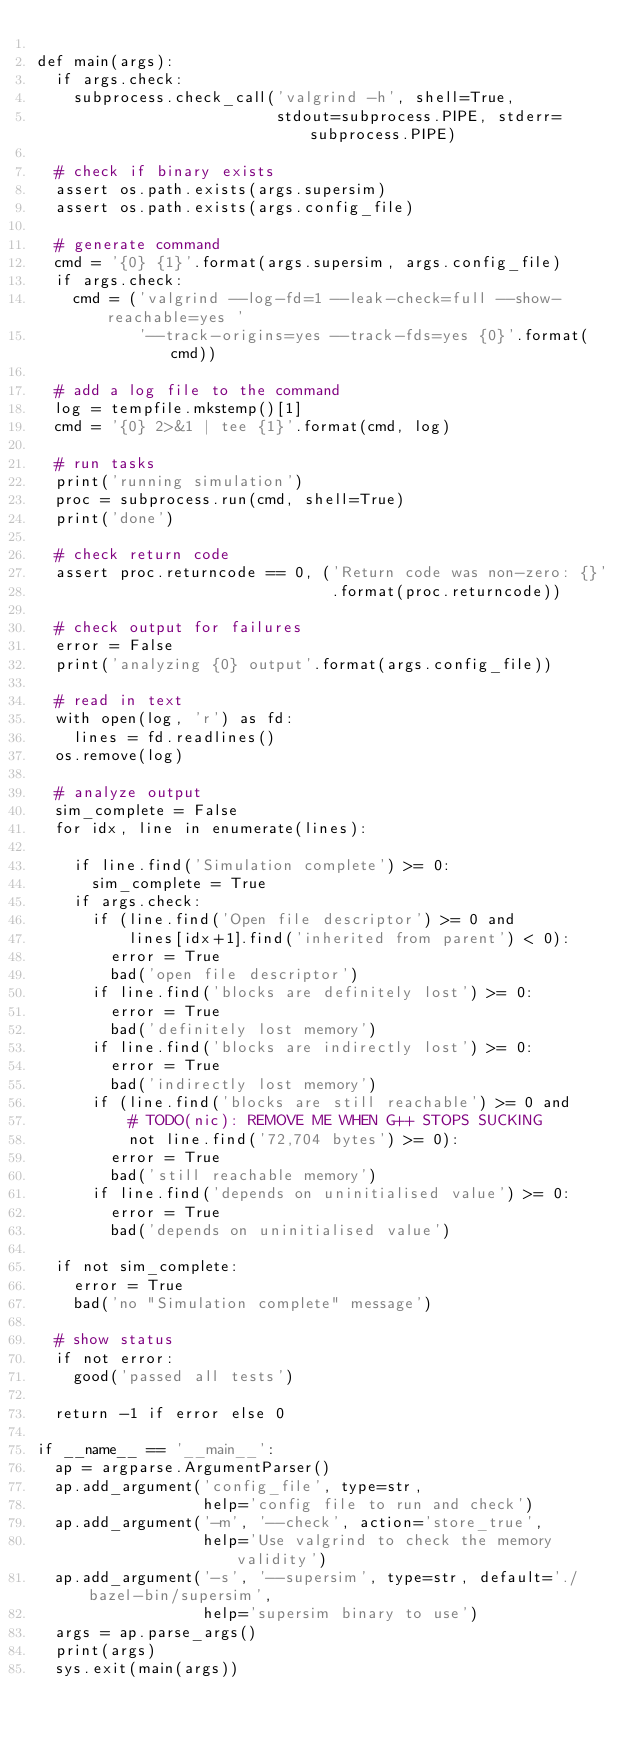<code> <loc_0><loc_0><loc_500><loc_500><_Python_>
def main(args):
  if args.check:
    subprocess.check_call('valgrind -h', shell=True,
                          stdout=subprocess.PIPE, stderr=subprocess.PIPE)

  # check if binary exists
  assert os.path.exists(args.supersim)
  assert os.path.exists(args.config_file)

  # generate command
  cmd = '{0} {1}'.format(args.supersim, args.config_file)
  if args.check:
    cmd = ('valgrind --log-fd=1 --leak-check=full --show-reachable=yes '
           '--track-origins=yes --track-fds=yes {0}'.format(cmd))

  # add a log file to the command
  log = tempfile.mkstemp()[1]
  cmd = '{0} 2>&1 | tee {1}'.format(cmd, log)

  # run tasks
  print('running simulation')
  proc = subprocess.run(cmd, shell=True)
  print('done')

  # check return code
  assert proc.returncode == 0, ('Return code was non-zero: {}'
                                .format(proc.returncode))

  # check output for failures
  error = False
  print('analyzing {0} output'.format(args.config_file))

  # read in text
  with open(log, 'r') as fd:
    lines = fd.readlines()
  os.remove(log)

  # analyze output
  sim_complete = False
  for idx, line in enumerate(lines):

    if line.find('Simulation complete') >= 0:
      sim_complete = True
    if args.check:
      if (line.find('Open file descriptor') >= 0 and
          lines[idx+1].find('inherited from parent') < 0):
        error = True
        bad('open file descriptor')
      if line.find('blocks are definitely lost') >= 0:
        error = True
        bad('definitely lost memory')
      if line.find('blocks are indirectly lost') >= 0:
        error = True
        bad('indirectly lost memory')
      if (line.find('blocks are still reachable') >= 0 and
          # TODO(nic): REMOVE ME WHEN G++ STOPS SUCKING
          not line.find('72,704 bytes') >= 0):
        error = True
        bad('still reachable memory')
      if line.find('depends on uninitialised value') >= 0:
        error = True
        bad('depends on uninitialised value')

  if not sim_complete:
    error = True
    bad('no "Simulation complete" message')

  # show status
  if not error:
    good('passed all tests')

  return -1 if error else 0

if __name__ == '__main__':
  ap = argparse.ArgumentParser()
  ap.add_argument('config_file', type=str,
                  help='config file to run and check')
  ap.add_argument('-m', '--check', action='store_true',
                  help='Use valgrind to check the memory validity')
  ap.add_argument('-s', '--supersim', type=str, default='./bazel-bin/supersim',
                  help='supersim binary to use')
  args = ap.parse_args()
  print(args)
  sys.exit(main(args))
</code> 